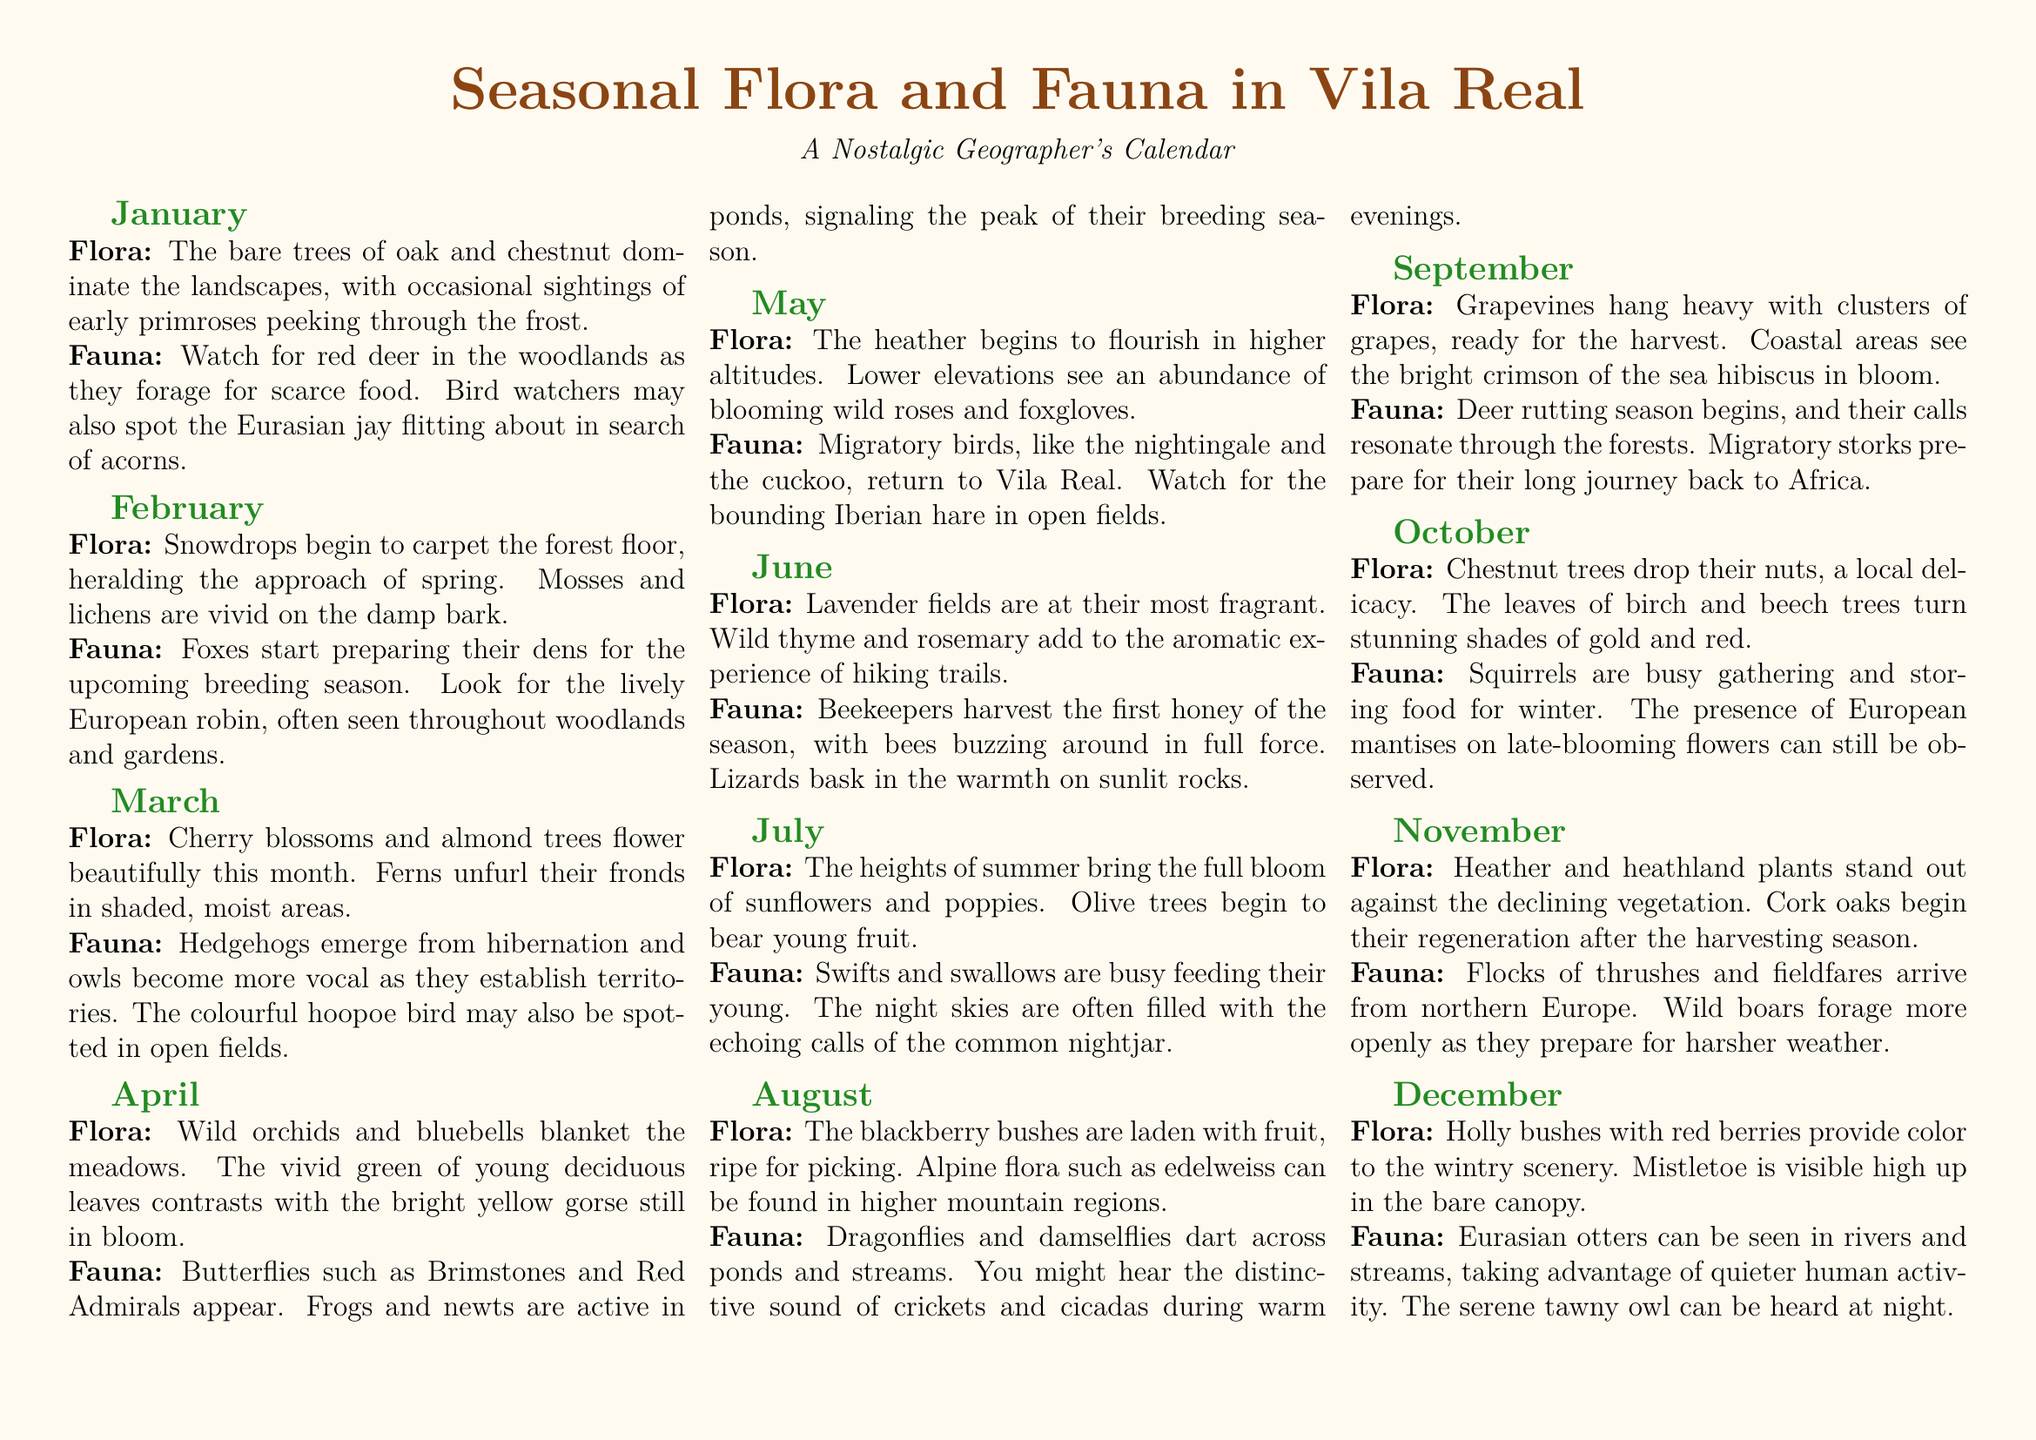What flora begins to carpet the forest floor in February? The document states that "Snowdrops begin to carpet the forest floor" in February.
Answer: Snowdrops Which bird is noted for being active in March? The document mentions that "Hedgehogs emerge from hibernation and owls become more vocal" in March, but specifically states the "colorful hoopoe bird may also be spotted."
Answer: Hoopoe What type of tree is mentioned for its nuts in October? The document identifies "Chestnut trees" as the type of tree that drops its nuts in October.
Answer: Chestnut trees Which insect appears during April's peak breeding season? The document notes that "frogs and newts are active in ponds, signaling the peak of their breeding season" in April.
Answer: Frogs What fruit do blackberry bushes bear in August? The document states that "The blackberry bushes are laden with fruit, ripe for picking" in August.
Answer: Blackberries How do the leaves of birch and beech trees change in October? The document says that "The leaves of birch and beech trees turn stunning shades of gold and red" in October.
Answer: Gold and red What animal is commonly seen foraging in November? According to the document, "Wild boars forage more openly as they prepare for harsher weather" in November.
Answer: Wild boars What is the significance of the month of December for Eurasian otters? The document indicates that "Eurasian otters can be seen in rivers and streams" taking advantage of "quieter human activity" in December.
Answer: Quieter human activity 